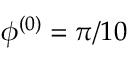<formula> <loc_0><loc_0><loc_500><loc_500>\phi ^ { ( 0 ) } = \pi / 1 0</formula> 